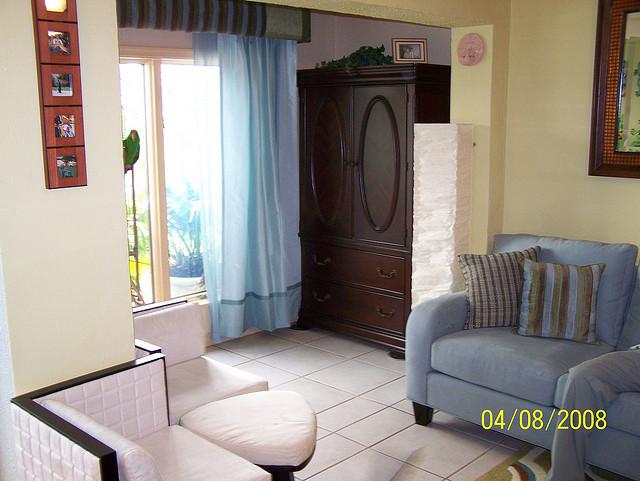Is there a window in the room?
Be succinct. Yes. What is the floor made of?
Short answer required. Tile. When was this picture taken?
Write a very short answer. 04/08/2008. 